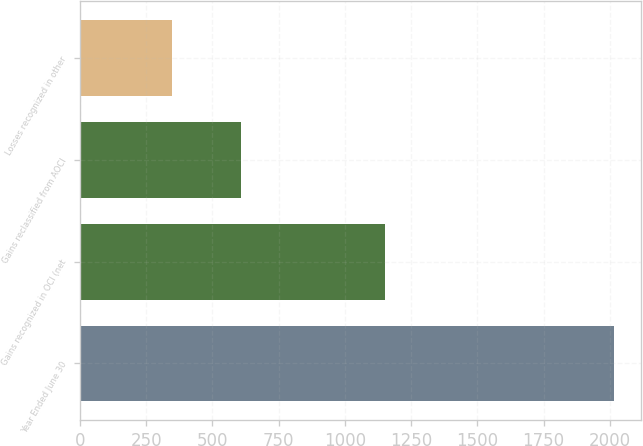<chart> <loc_0><loc_0><loc_500><loc_500><bar_chart><fcel>Year Ended June 30<fcel>Gains recognized in OCI (net<fcel>Gains reclassified from AOCI<fcel>Losses recognized in other<nl><fcel>2015<fcel>1152<fcel>608<fcel>346<nl></chart> 